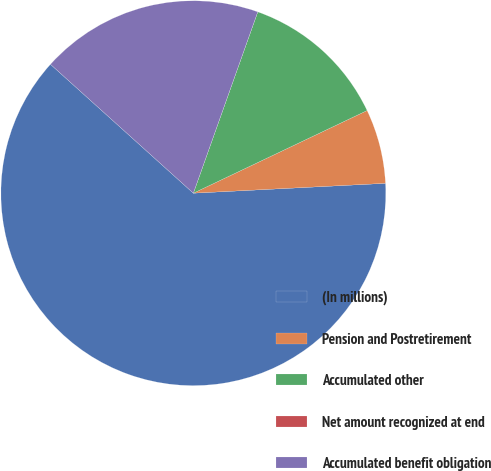<chart> <loc_0><loc_0><loc_500><loc_500><pie_chart><fcel>(In millions)<fcel>Pension and Postretirement<fcel>Accumulated other<fcel>Net amount recognized at end<fcel>Accumulated benefit obligation<nl><fcel>62.49%<fcel>6.25%<fcel>12.5%<fcel>0.0%<fcel>18.75%<nl></chart> 